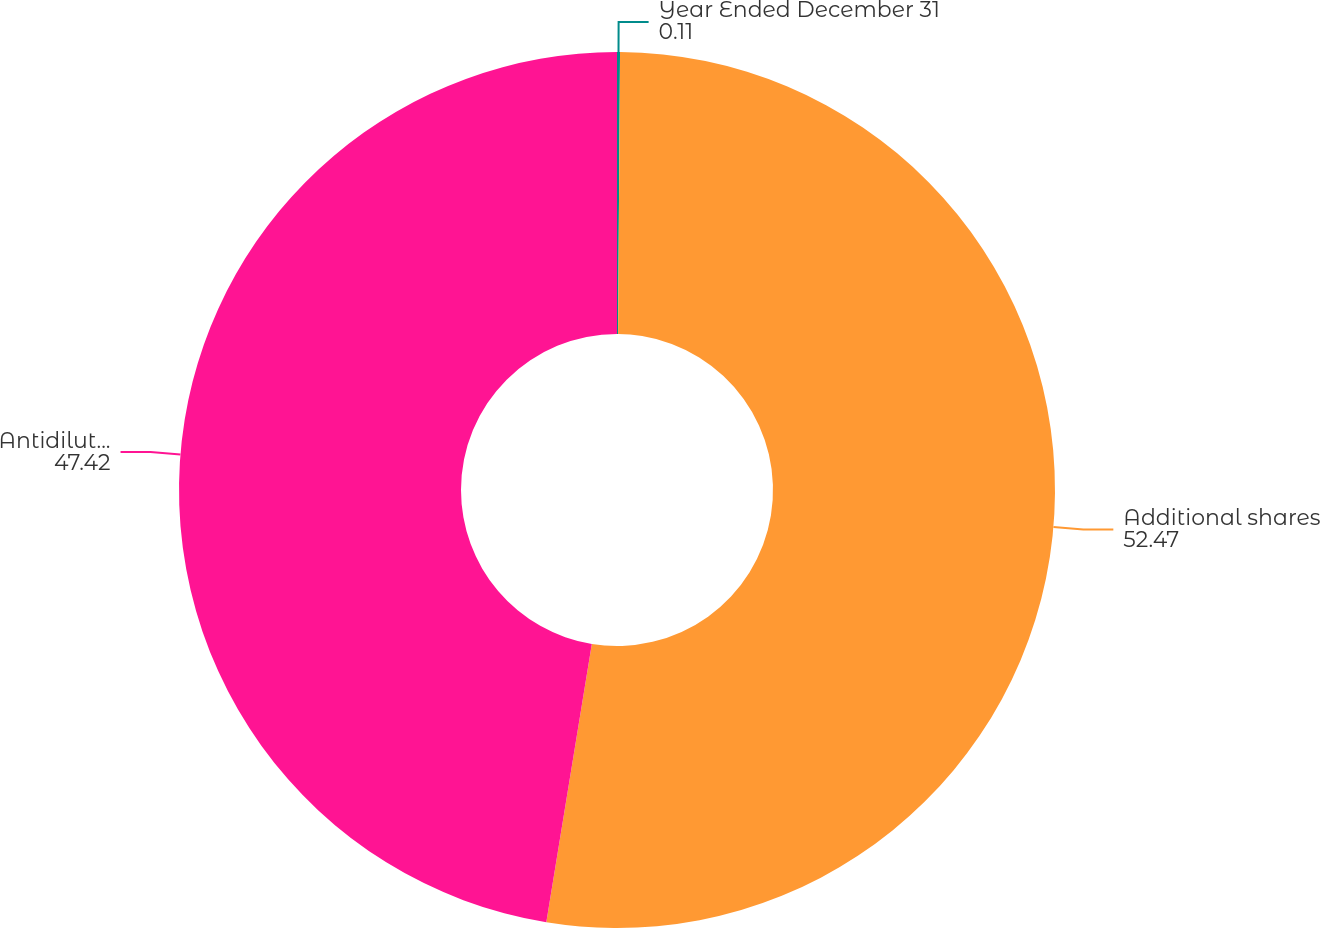<chart> <loc_0><loc_0><loc_500><loc_500><pie_chart><fcel>Year Ended December 31<fcel>Additional shares<fcel>Antidilutive options<nl><fcel>0.11%<fcel>52.47%<fcel>47.42%<nl></chart> 